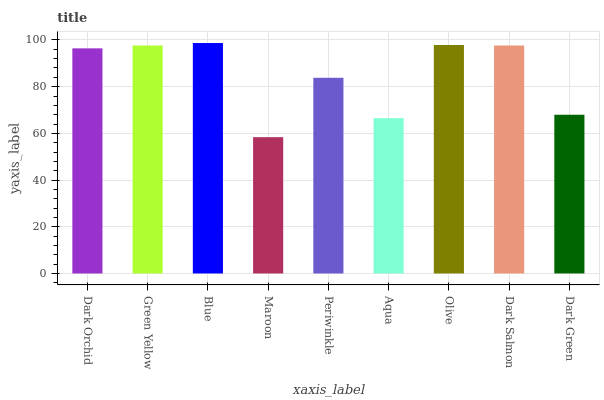Is Maroon the minimum?
Answer yes or no. Yes. Is Blue the maximum?
Answer yes or no. Yes. Is Green Yellow the minimum?
Answer yes or no. No. Is Green Yellow the maximum?
Answer yes or no. No. Is Green Yellow greater than Dark Orchid?
Answer yes or no. Yes. Is Dark Orchid less than Green Yellow?
Answer yes or no. Yes. Is Dark Orchid greater than Green Yellow?
Answer yes or no. No. Is Green Yellow less than Dark Orchid?
Answer yes or no. No. Is Dark Orchid the high median?
Answer yes or no. Yes. Is Dark Orchid the low median?
Answer yes or no. Yes. Is Maroon the high median?
Answer yes or no. No. Is Dark Green the low median?
Answer yes or no. No. 